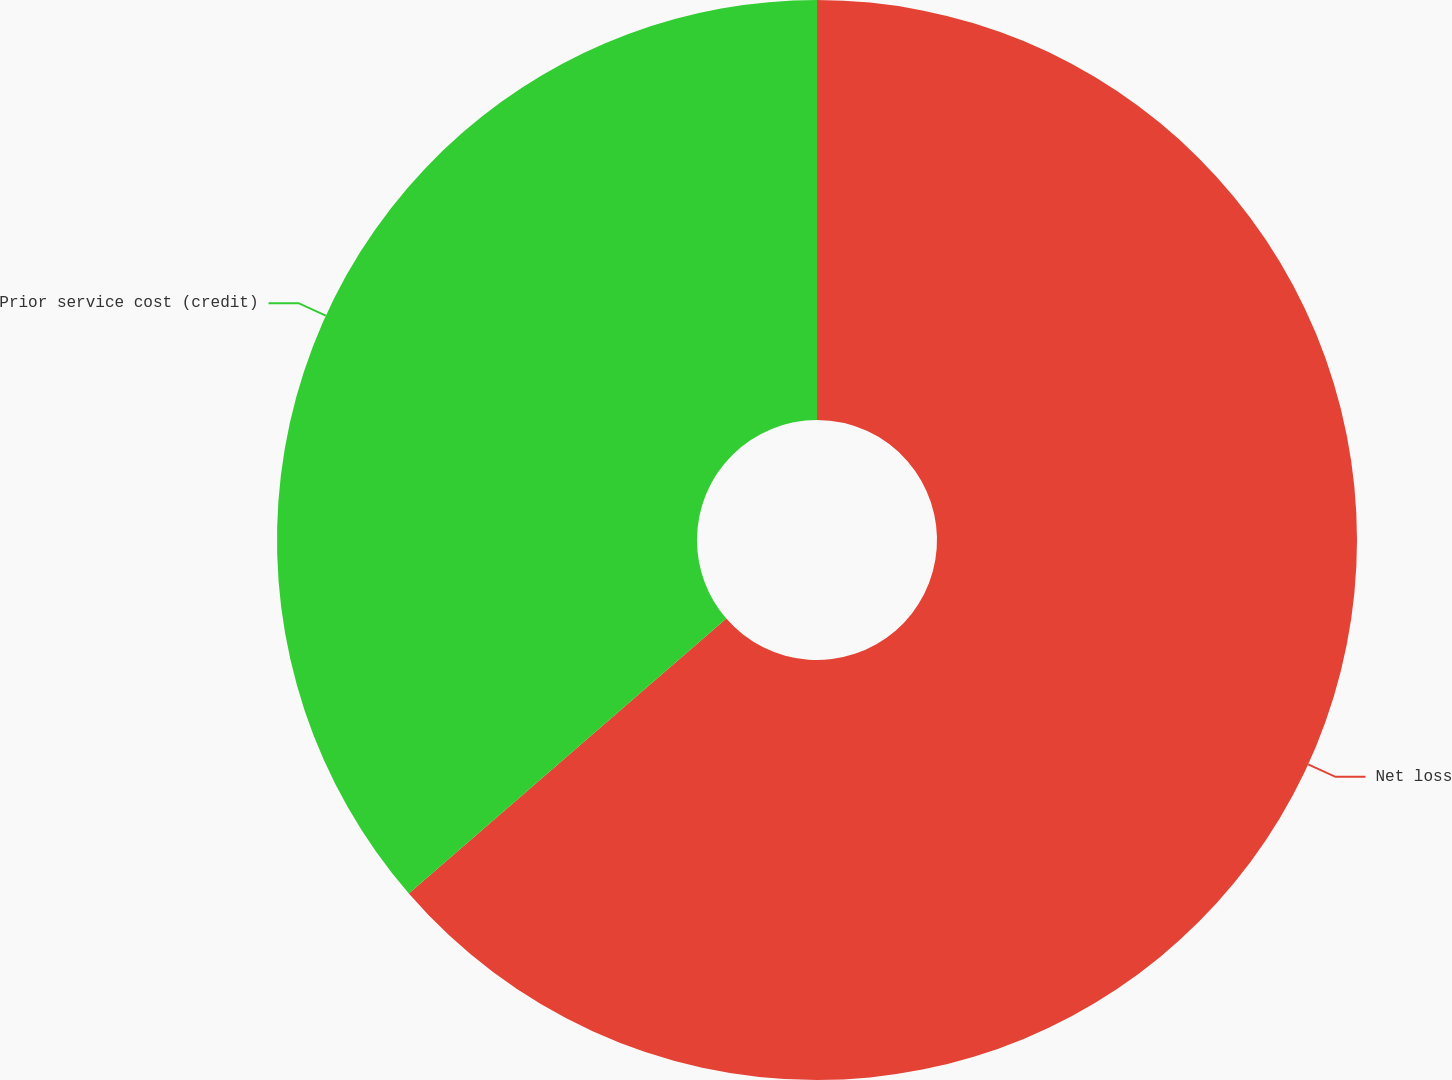Convert chart. <chart><loc_0><loc_0><loc_500><loc_500><pie_chart><fcel>Net loss<fcel>Prior service cost (credit)<nl><fcel>63.64%<fcel>36.36%<nl></chart> 